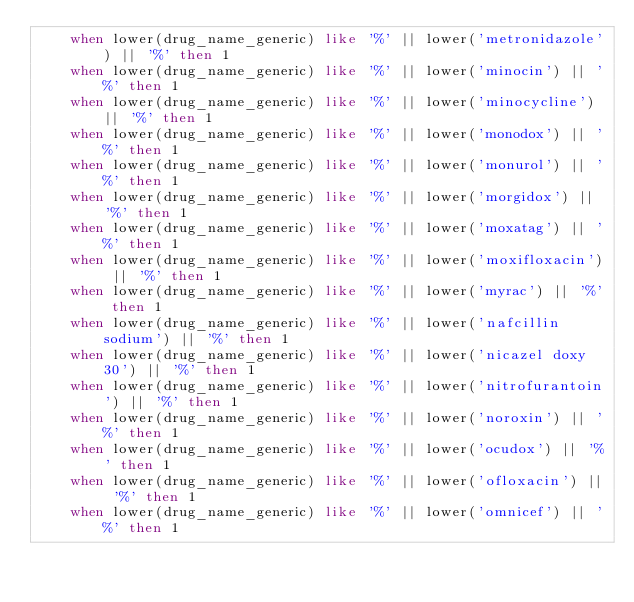Convert code to text. <code><loc_0><loc_0><loc_500><loc_500><_SQL_>    when lower(drug_name_generic) like '%' || lower('metronidazole') || '%' then 1
    when lower(drug_name_generic) like '%' || lower('minocin') || '%' then 1
    when lower(drug_name_generic) like '%' || lower('minocycline') || '%' then 1
    when lower(drug_name_generic) like '%' || lower('monodox') || '%' then 1
    when lower(drug_name_generic) like '%' || lower('monurol') || '%' then 1
    when lower(drug_name_generic) like '%' || lower('morgidox') || '%' then 1
    when lower(drug_name_generic) like '%' || lower('moxatag') || '%' then 1
    when lower(drug_name_generic) like '%' || lower('moxifloxacin') || '%' then 1
    when lower(drug_name_generic) like '%' || lower('myrac') || '%' then 1
    when lower(drug_name_generic) like '%' || lower('nafcillin sodium') || '%' then 1
    when lower(drug_name_generic) like '%' || lower('nicazel doxy 30') || '%' then 1
    when lower(drug_name_generic) like '%' || lower('nitrofurantoin') || '%' then 1
    when lower(drug_name_generic) like '%' || lower('noroxin') || '%' then 1
    when lower(drug_name_generic) like '%' || lower('ocudox') || '%' then 1
    when lower(drug_name_generic) like '%' || lower('ofloxacin') || '%' then 1
    when lower(drug_name_generic) like '%' || lower('omnicef') || '%' then 1</code> 